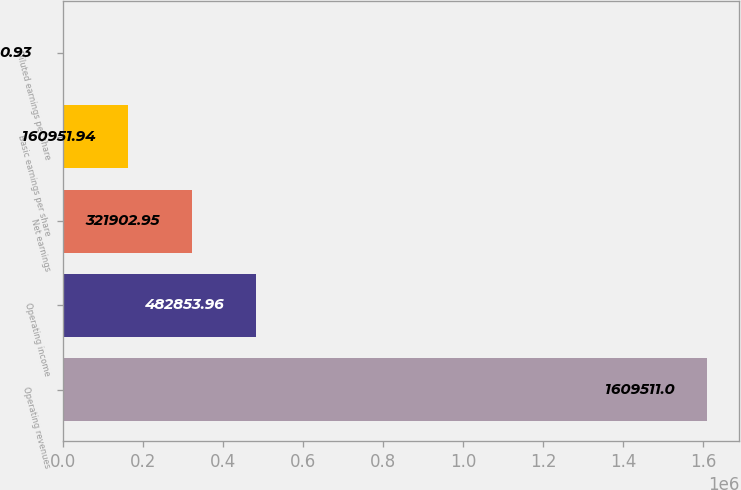<chart> <loc_0><loc_0><loc_500><loc_500><bar_chart><fcel>Operating revenues<fcel>Operating income<fcel>Net earnings<fcel>Basic earnings per share<fcel>Diluted earnings per share<nl><fcel>1.60951e+06<fcel>482854<fcel>321903<fcel>160952<fcel>0.93<nl></chart> 